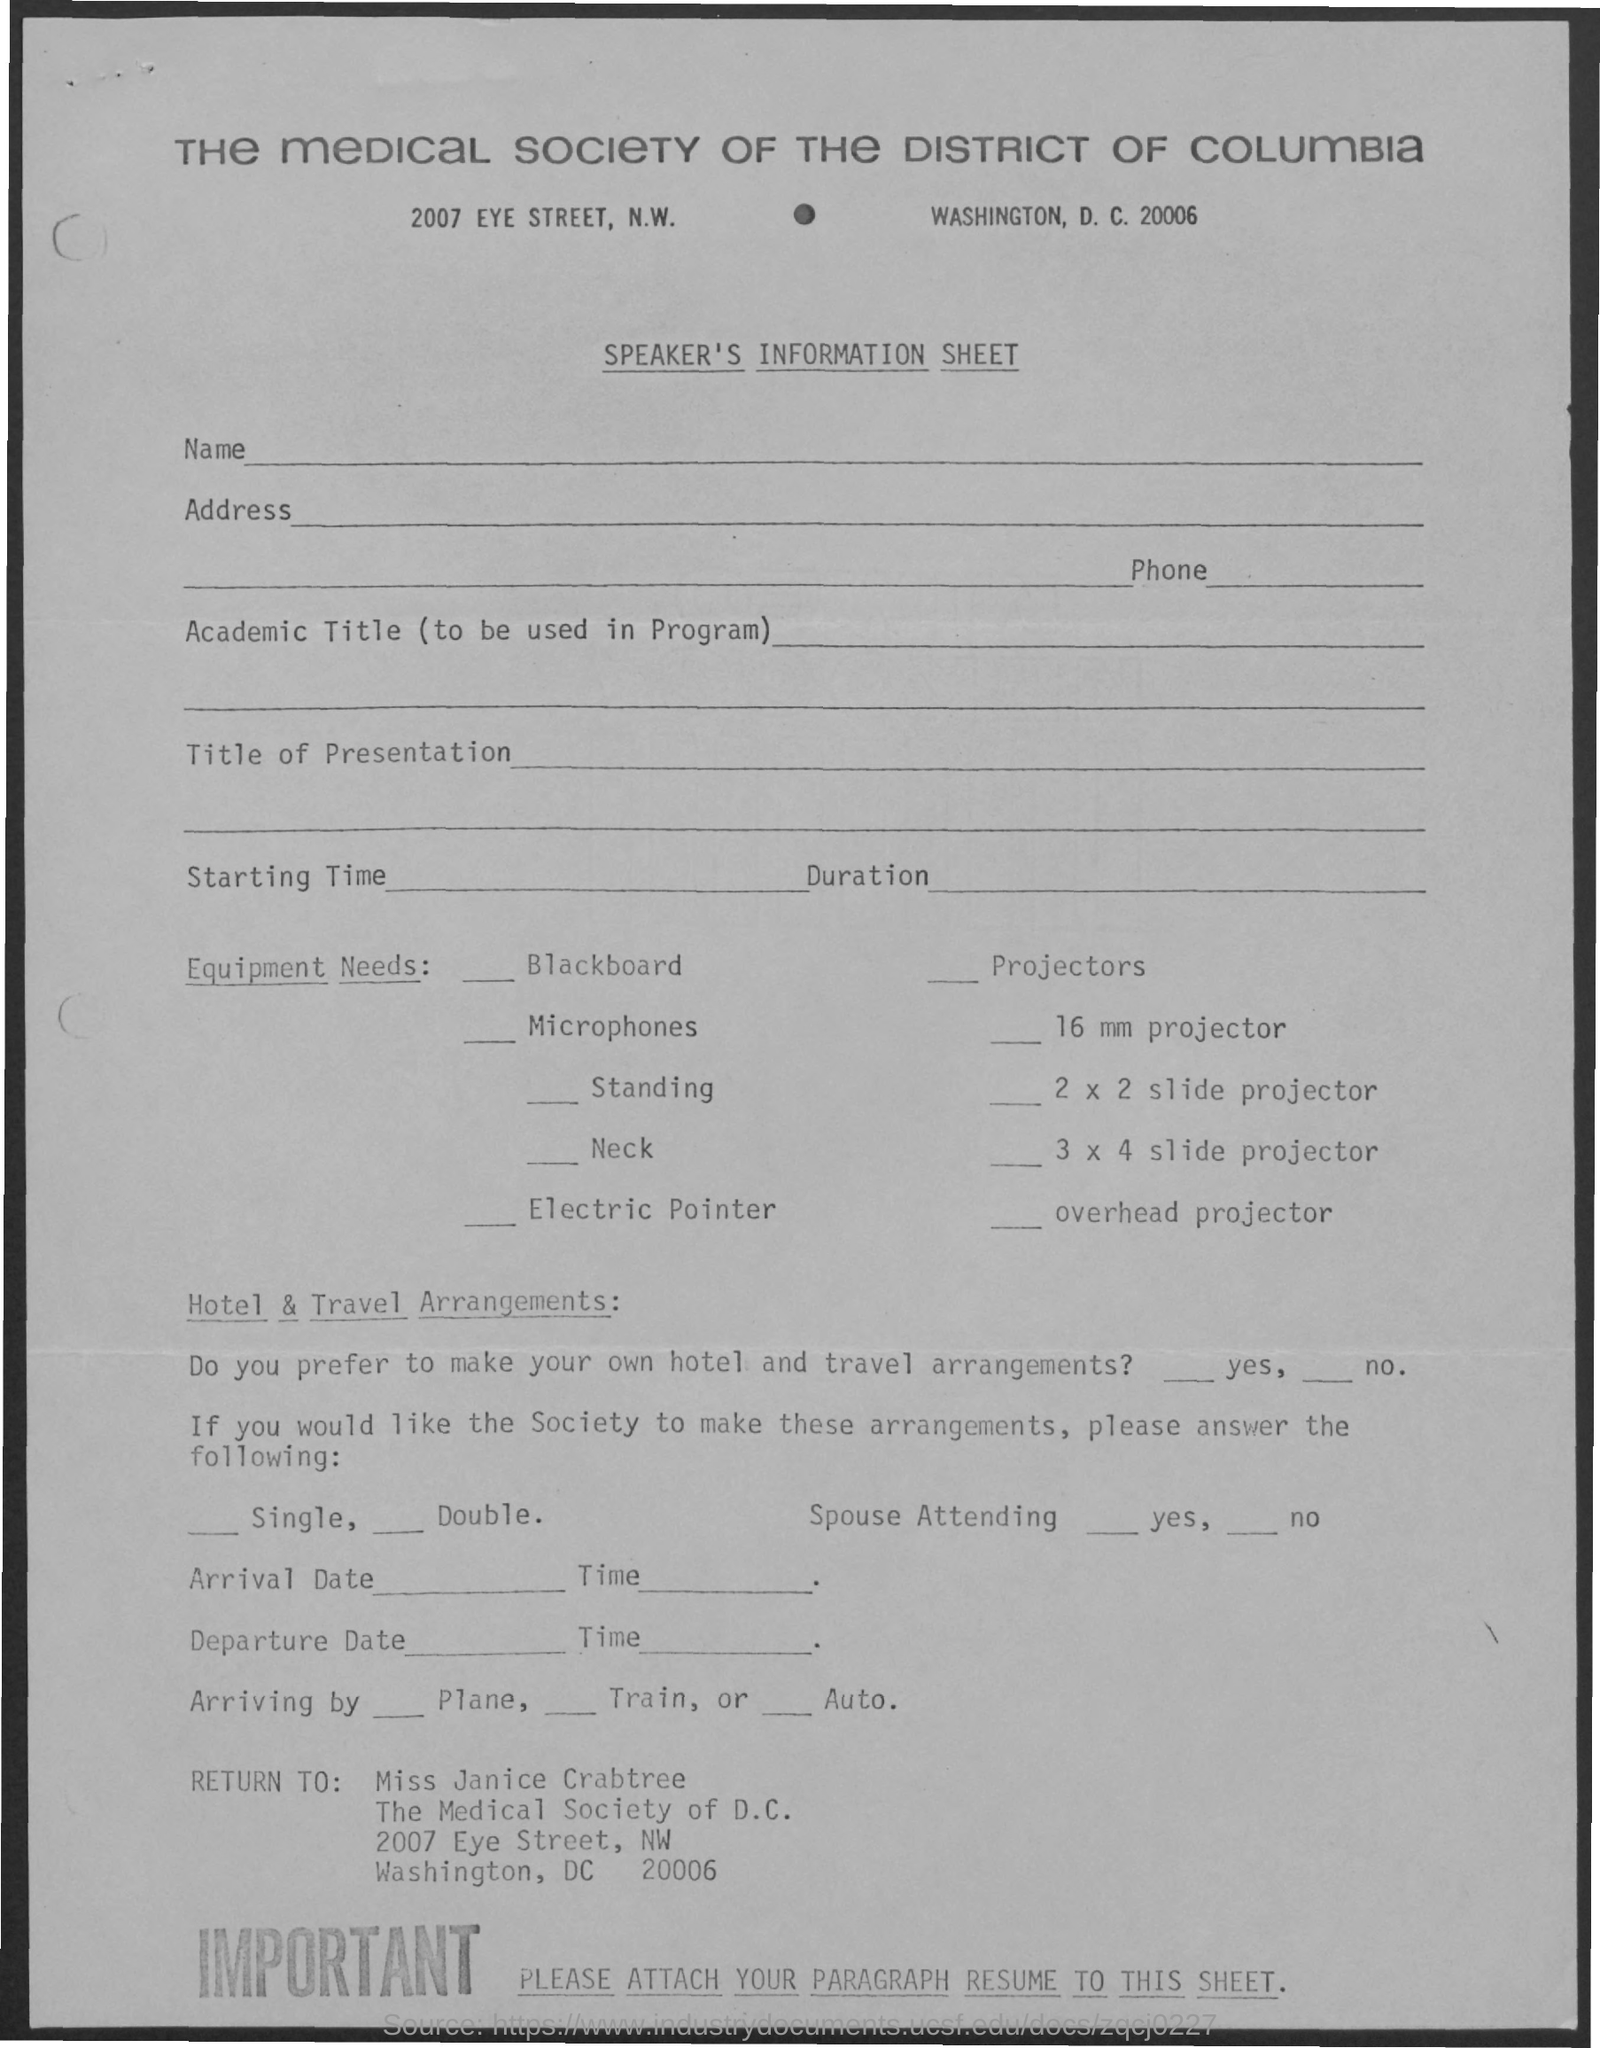Indicate a few pertinent items in this graphic. The name of the person mentioned in the return is Miss Janice Crabtree. 